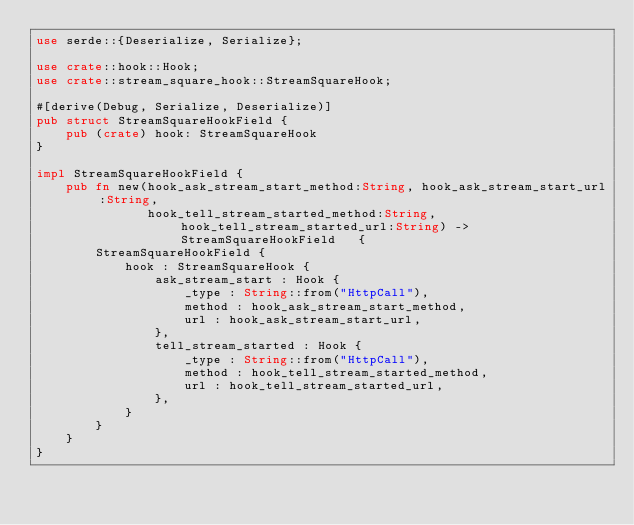Convert code to text. <code><loc_0><loc_0><loc_500><loc_500><_Rust_>use serde::{Deserialize, Serialize};

use crate::hook::Hook;
use crate::stream_square_hook::StreamSquareHook;

#[derive(Debug, Serialize, Deserialize)]
pub struct StreamSquareHookField {
    pub (crate) hook: StreamSquareHook
}

impl StreamSquareHookField {
    pub fn new(hook_ask_stream_start_method:String, hook_ask_stream_start_url:String,
               hook_tell_stream_started_method:String, hook_tell_stream_started_url:String) -> StreamSquareHookField   {
        StreamSquareHookField {
            hook : StreamSquareHook {
                ask_stream_start : Hook {
                    _type : String::from("HttpCall"),
                    method : hook_ask_stream_start_method,
                    url : hook_ask_stream_start_url,
                },
                tell_stream_started : Hook {
                    _type : String::from("HttpCall"),
                    method : hook_tell_stream_started_method,
                    url : hook_tell_stream_started_url,
                },
            }
        }
    }
}</code> 